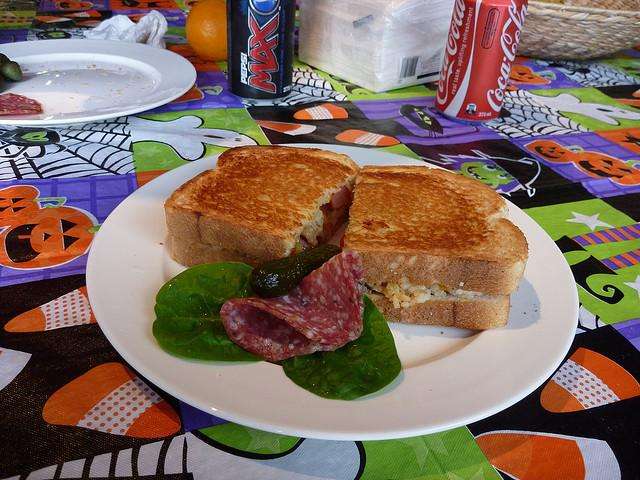What is the side dish? pickle 